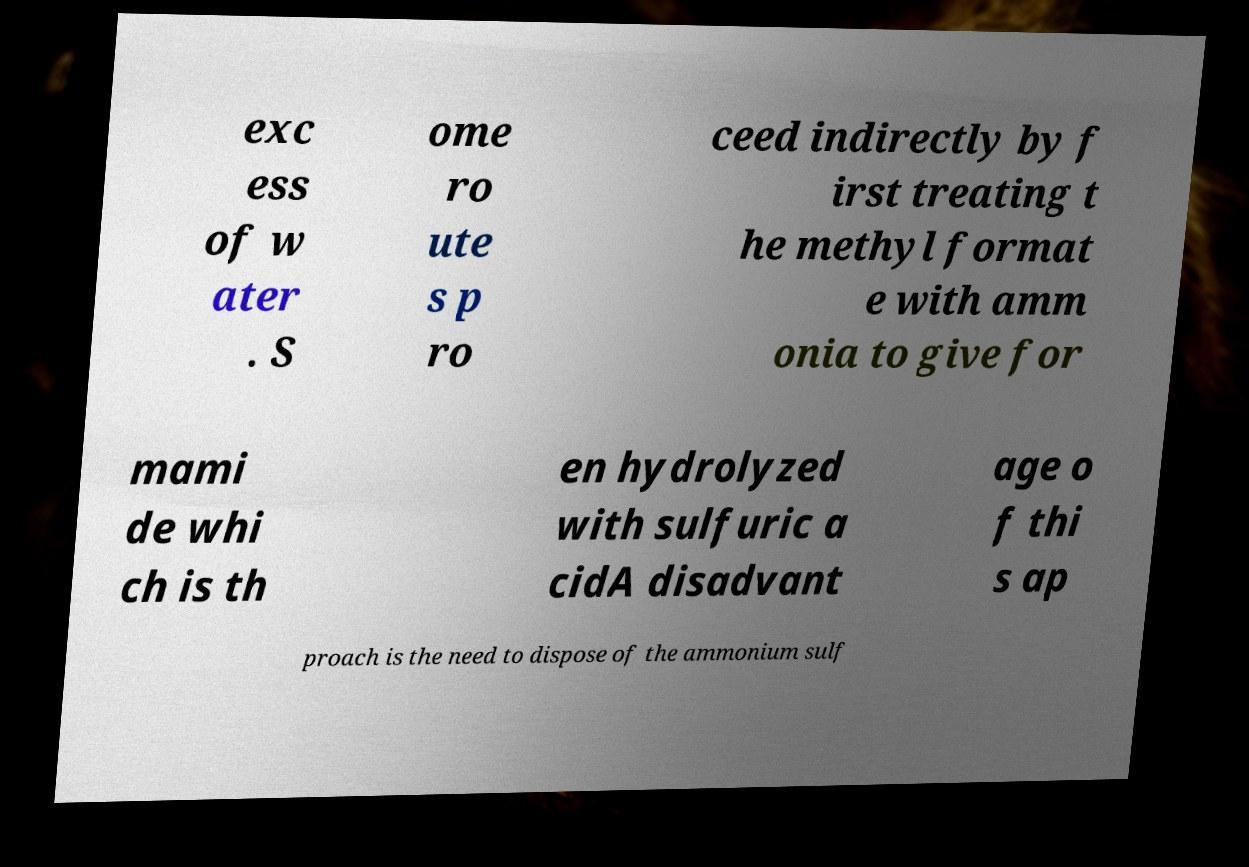Can you accurately transcribe the text from the provided image for me? exc ess of w ater . S ome ro ute s p ro ceed indirectly by f irst treating t he methyl format e with amm onia to give for mami de whi ch is th en hydrolyzed with sulfuric a cidA disadvant age o f thi s ap proach is the need to dispose of the ammonium sulf 